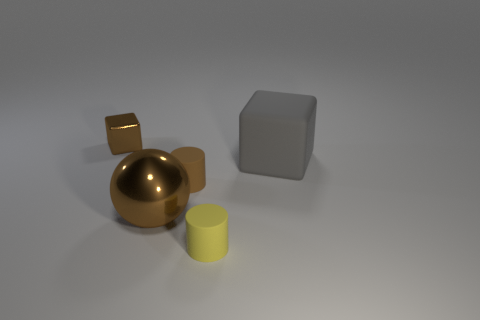What could be the purpose of arranging these objects this way? The arrangement of these objects may serve an artistic or illustrative purpose, potentially to showcase the play of light and shadow on different shapes and materials. It could also be a part of a visual composition study in photography or 3D modeling, exploring how objects of varying textures and reflectivity interact with light within a controlled environment. 